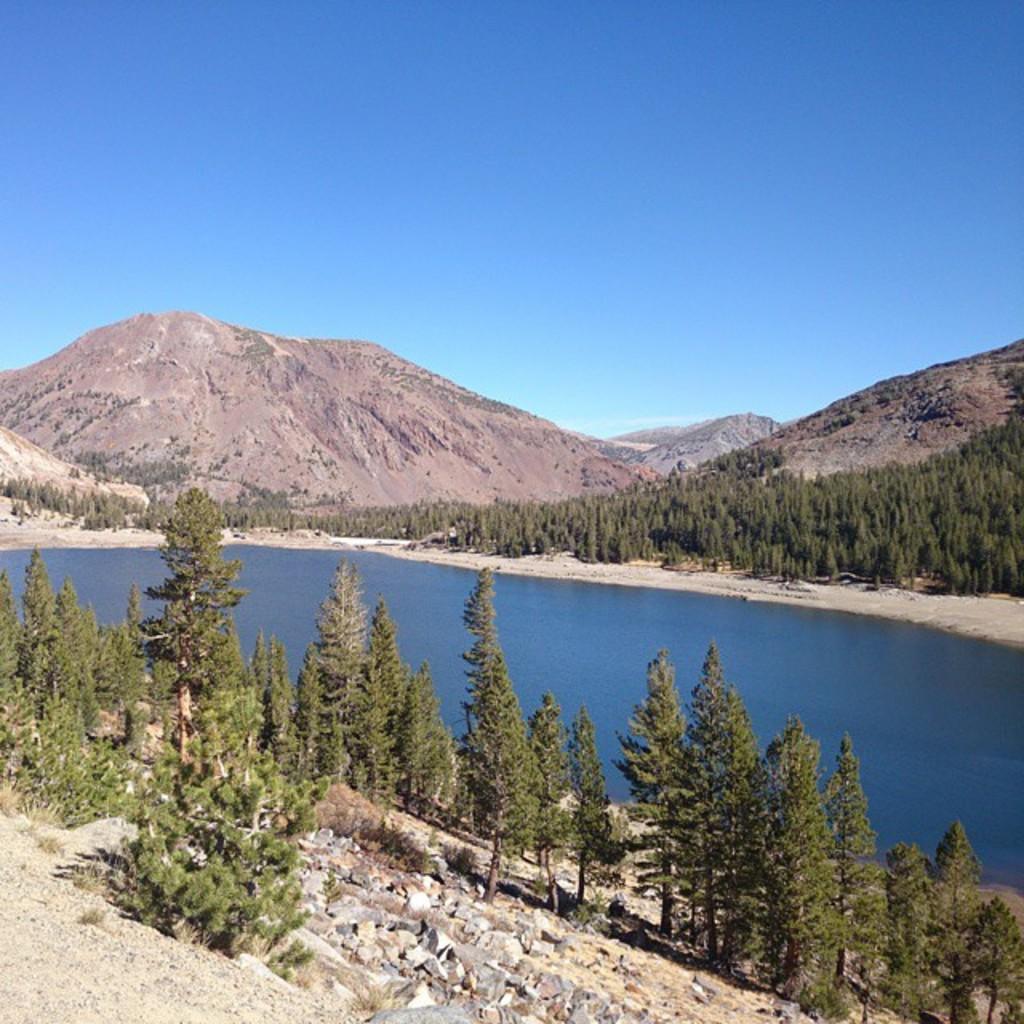Describe this image in one or two sentences. These are the trees. I can see the water. I think these are the mountains. I can see the rocks. This is the sky. 